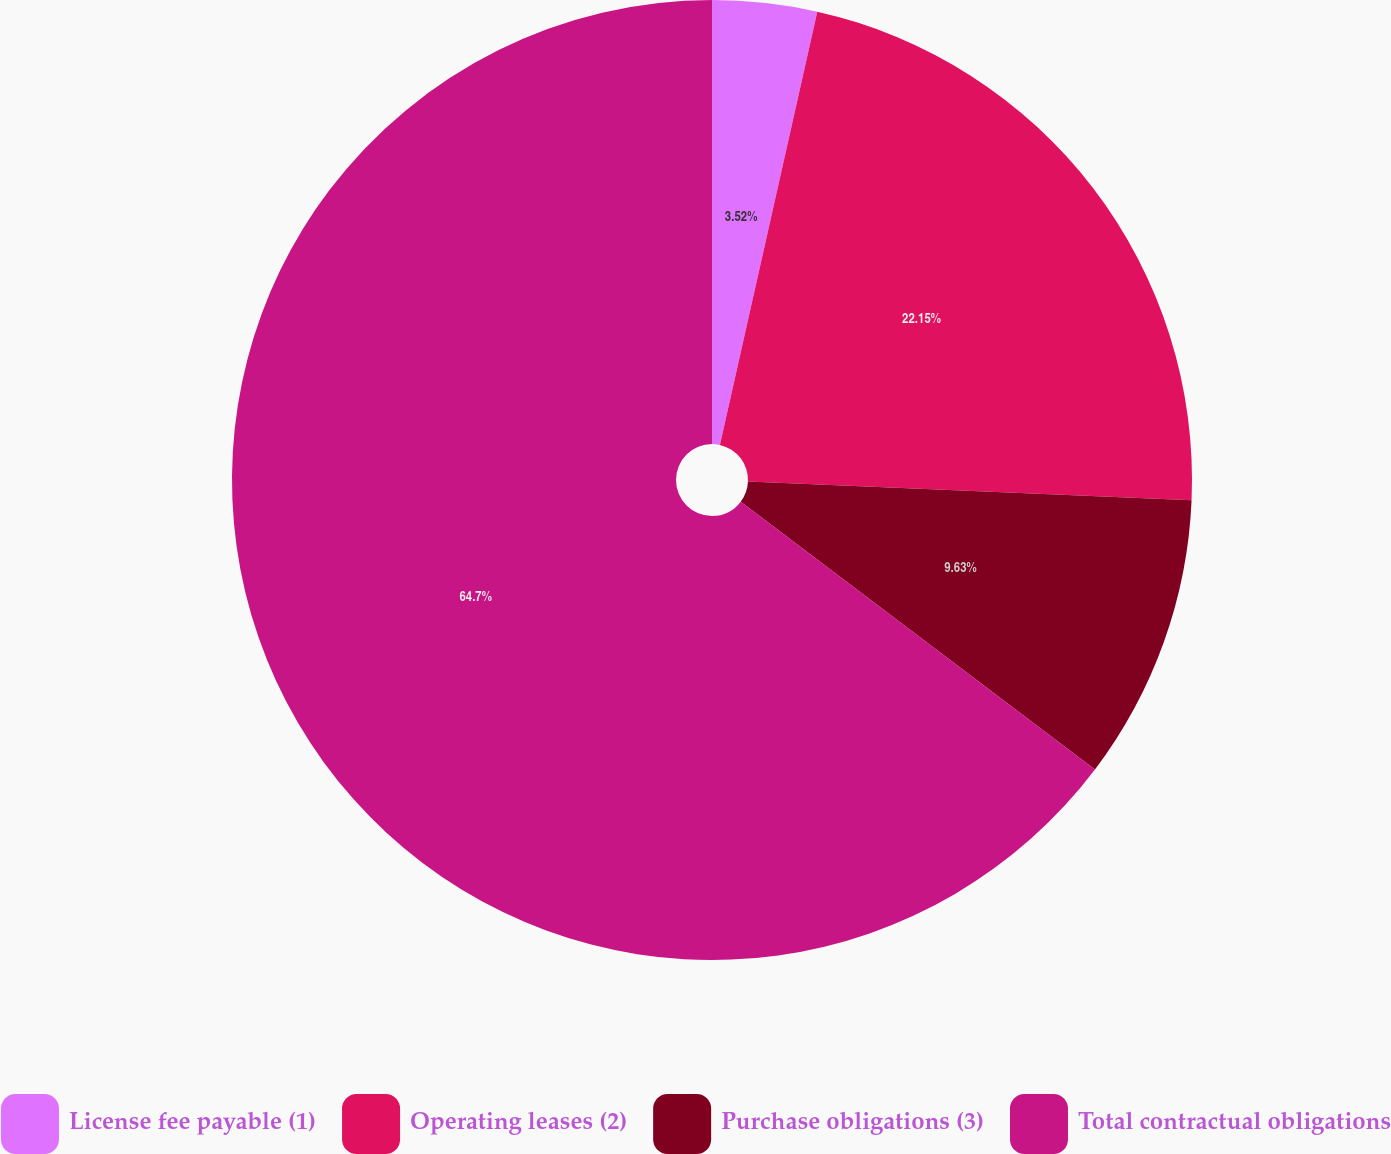Convert chart. <chart><loc_0><loc_0><loc_500><loc_500><pie_chart><fcel>License fee payable (1)<fcel>Operating leases (2)<fcel>Purchase obligations (3)<fcel>Total contractual obligations<nl><fcel>3.52%<fcel>22.15%<fcel>9.63%<fcel>64.7%<nl></chart> 